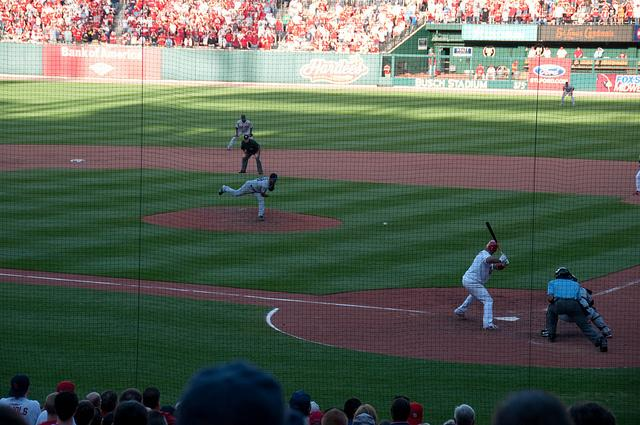What play is the best case scenario for the batter?

Choices:
A) home run
B) foul
C) walk
D) strike out home run 